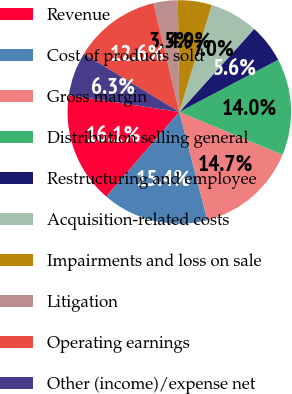Convert chart. <chart><loc_0><loc_0><loc_500><loc_500><pie_chart><fcel>Revenue<fcel>Cost of products sold<fcel>Gross margin<fcel>Distribution selling general<fcel>Restructuring and employee<fcel>Acquisition-related costs<fcel>Impairments and loss on sale<fcel>Litigation<fcel>Operating earnings<fcel>Other (income)/expense net<nl><fcel>16.08%<fcel>15.38%<fcel>14.69%<fcel>13.99%<fcel>5.59%<fcel>6.99%<fcel>4.9%<fcel>3.5%<fcel>12.59%<fcel>6.29%<nl></chart> 